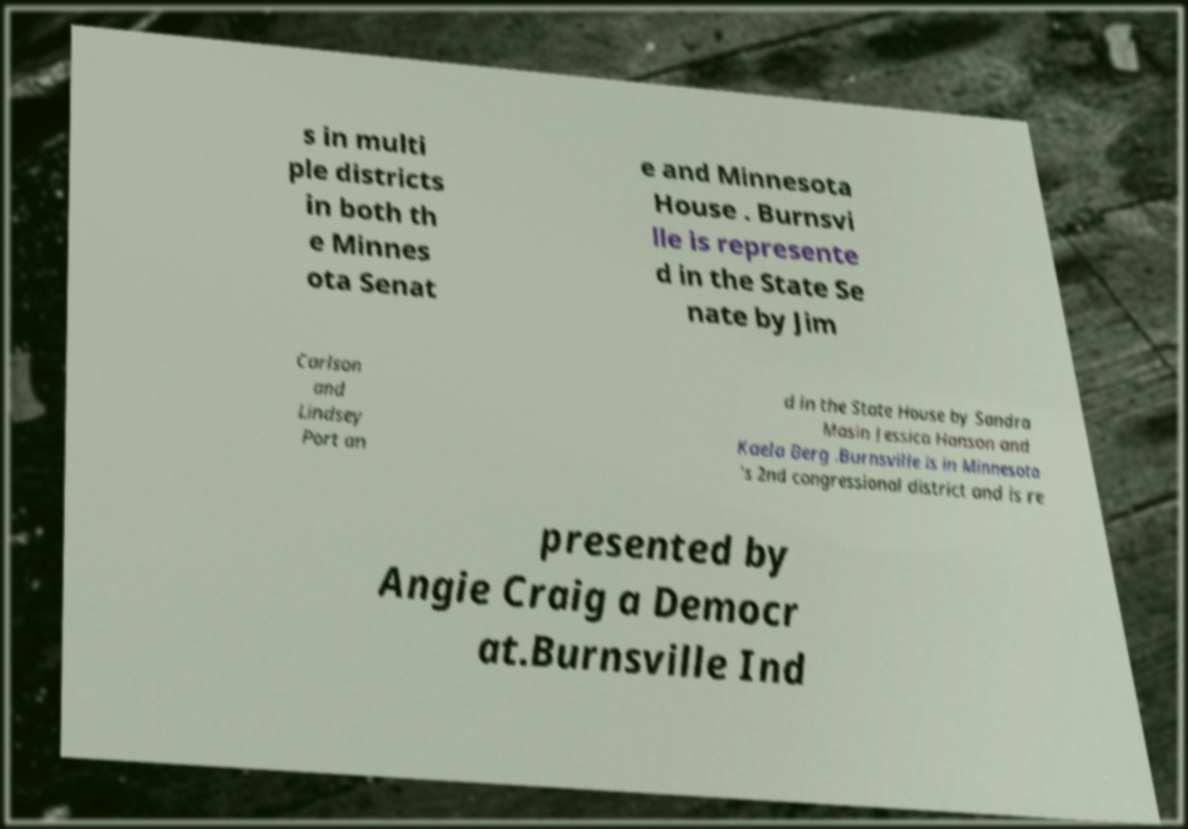There's text embedded in this image that I need extracted. Can you transcribe it verbatim? s in multi ple districts in both th e Minnes ota Senat e and Minnesota House . Burnsvi lle is represente d in the State Se nate by Jim Carlson and Lindsey Port an d in the State House by Sandra Masin Jessica Hanson and Kaela Berg .Burnsville is in Minnesota 's 2nd congressional district and is re presented by Angie Craig a Democr at.Burnsville Ind 